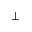Convert formula to latex. <formula><loc_0><loc_0><loc_500><loc_500>\perp</formula> 